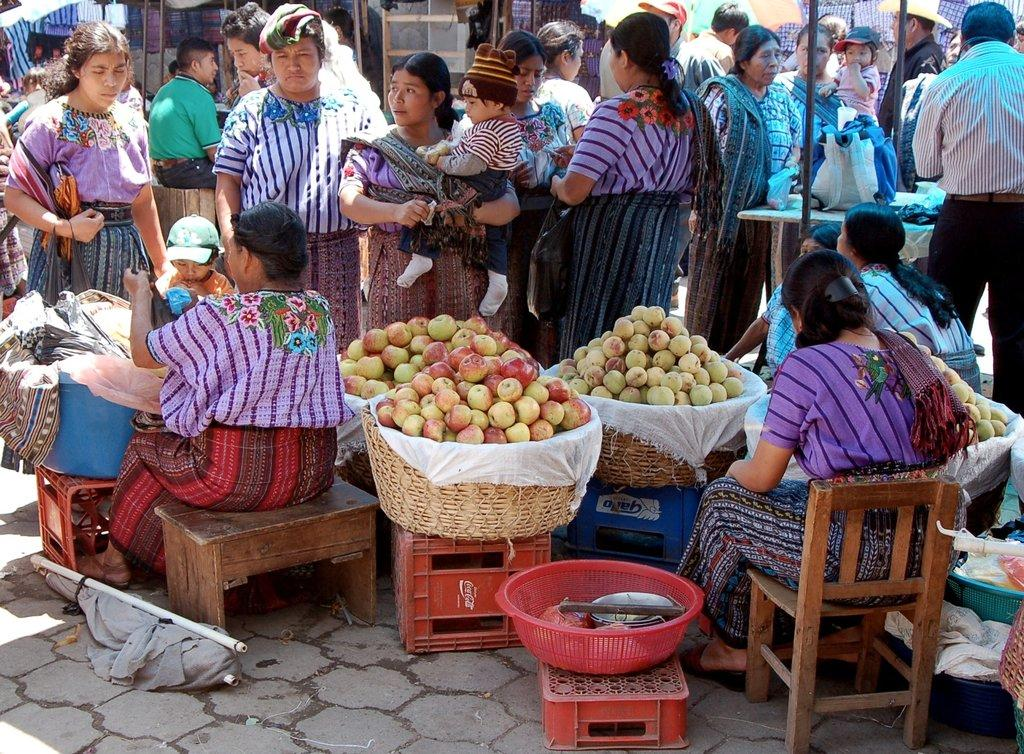What are the people in the image doing? Some people are sitting on the floor, while others are standing on the floor. What can be found in the basket in the image? The basket contains fruits. What type of cream is being used by the team in the image? There is no team or cream present in the image. 